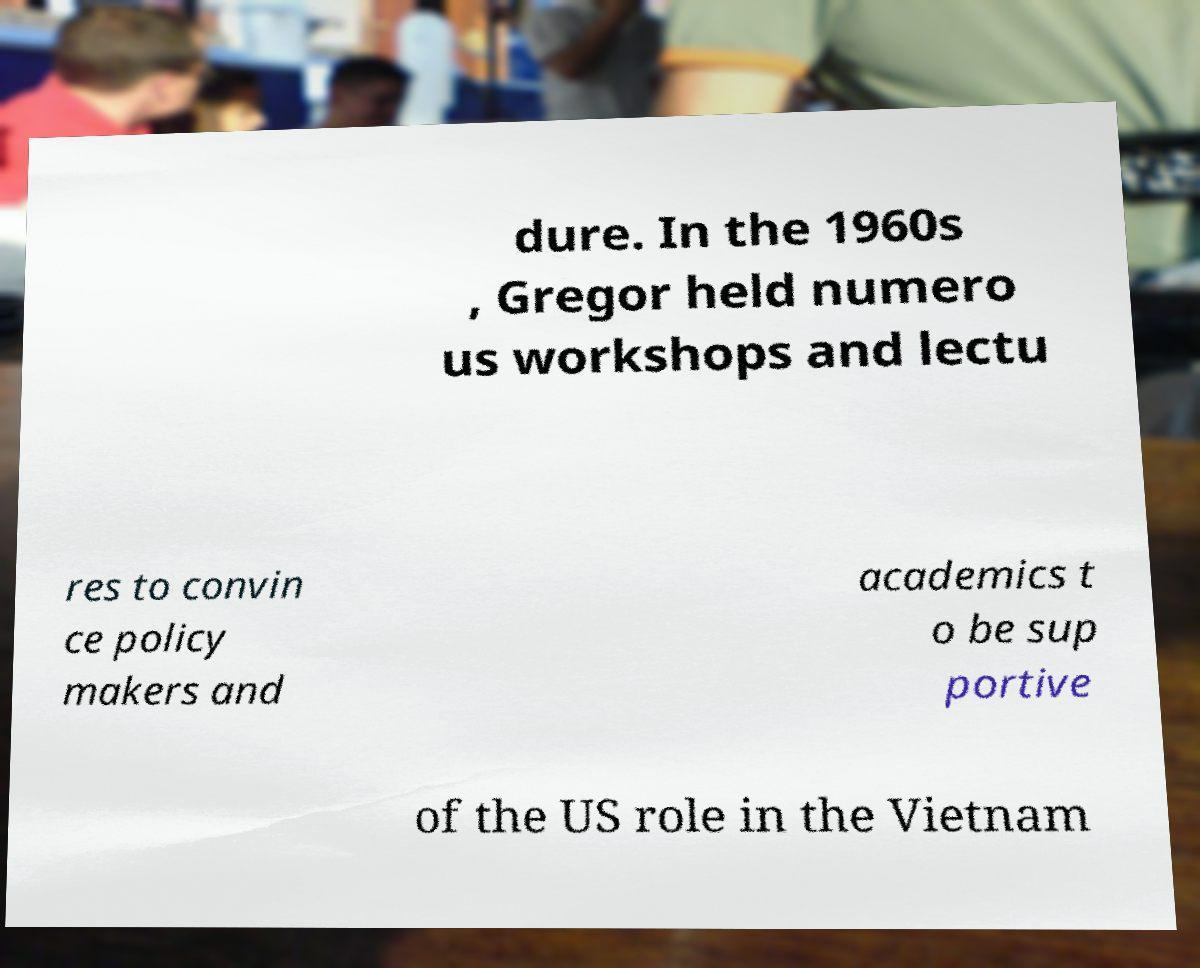Can you read and provide the text displayed in the image?This photo seems to have some interesting text. Can you extract and type it out for me? dure. In the 1960s , Gregor held numero us workshops and lectu res to convin ce policy makers and academics t o be sup portive of the US role in the Vietnam 